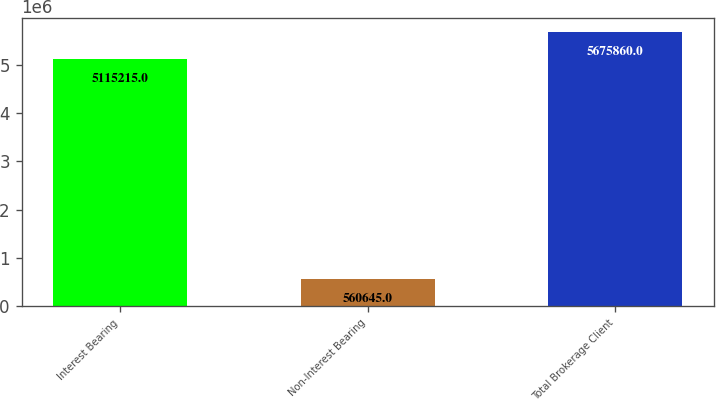Convert chart. <chart><loc_0><loc_0><loc_500><loc_500><bar_chart><fcel>Interest Bearing<fcel>Non-Interest Bearing<fcel>Total Brokerage Client<nl><fcel>5.11522e+06<fcel>560645<fcel>5.67586e+06<nl></chart> 